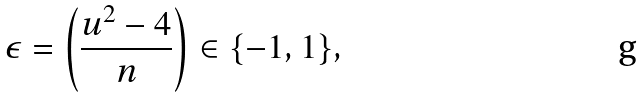<formula> <loc_0><loc_0><loc_500><loc_500>\epsilon = \left ( \frac { u ^ { 2 } - 4 } { n } \right ) \in \{ - 1 , 1 \} ,</formula> 